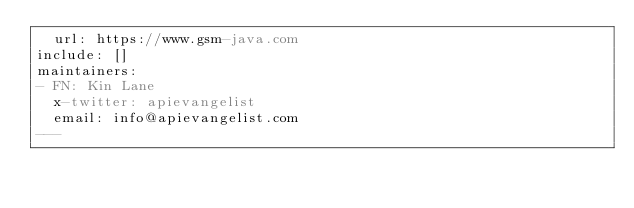<code> <loc_0><loc_0><loc_500><loc_500><_YAML_>  url: https://www.gsm-java.com
include: []
maintainers:
- FN: Kin Lane
  x-twitter: apievangelist
  email: info@apievangelist.com
---</code> 